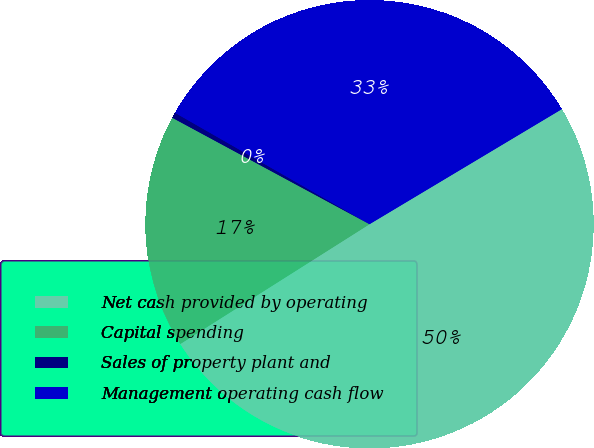<chart> <loc_0><loc_0><loc_500><loc_500><pie_chart><fcel>Net cash provided by operating<fcel>Capital spending<fcel>Sales of property plant and<fcel>Management operating cash flow<nl><fcel>49.6%<fcel>16.86%<fcel>0.4%<fcel>33.14%<nl></chart> 